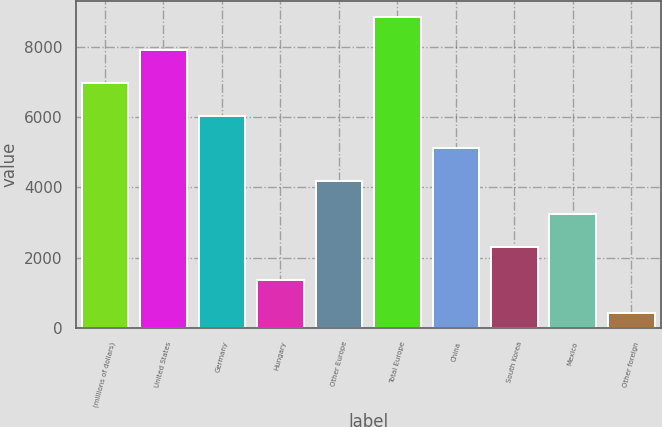Convert chart to OTSL. <chart><loc_0><loc_0><loc_500><loc_500><bar_chart><fcel>(millions of dollars)<fcel>United States<fcel>Germany<fcel>Hungary<fcel>Other Europe<fcel>Total Europe<fcel>China<fcel>South Korea<fcel>Mexico<fcel>Other foreign<nl><fcel>6987.28<fcel>7924.62<fcel>6049.94<fcel>1363.24<fcel>4175.26<fcel>8861.96<fcel>5112.6<fcel>2300.58<fcel>3237.92<fcel>425.9<nl></chart> 